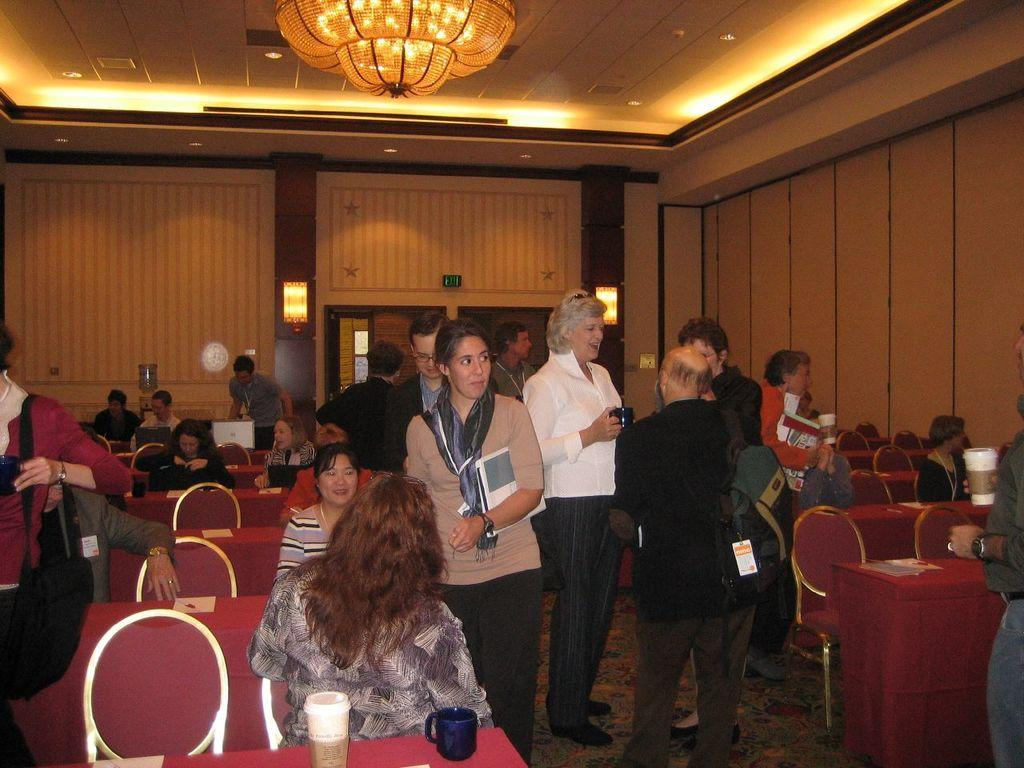What are the people in the image doing? There are people sitting on chairs and standing in the image. Can you describe the positions of the people in the image? Some people are sitting on chairs, while others are standing. How many cats can be seen riding on the trains in the image? There are no cats or trains present in the image. 